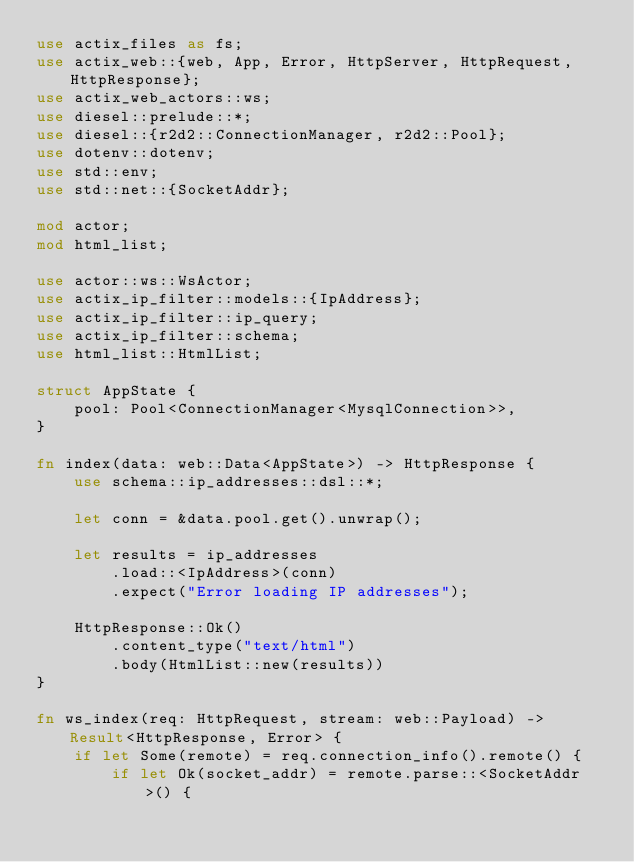<code> <loc_0><loc_0><loc_500><loc_500><_Rust_>use actix_files as fs;
use actix_web::{web, App, Error, HttpServer, HttpRequest, HttpResponse};
use actix_web_actors::ws;
use diesel::prelude::*;
use diesel::{r2d2::ConnectionManager, r2d2::Pool};
use dotenv::dotenv;
use std::env;
use std::net::{SocketAddr};

mod actor;
mod html_list;

use actor::ws::WsActor;
use actix_ip_filter::models::{IpAddress};
use actix_ip_filter::ip_query;
use actix_ip_filter::schema;
use html_list::HtmlList;

struct AppState {
    pool: Pool<ConnectionManager<MysqlConnection>>,
}

fn index(data: web::Data<AppState>) -> HttpResponse {
    use schema::ip_addresses::dsl::*;

    let conn = &data.pool.get().unwrap();

    let results = ip_addresses
        .load::<IpAddress>(conn)
        .expect("Error loading IP addresses");

    HttpResponse::Ok()
        .content_type("text/html")
        .body(HtmlList::new(results))
}

fn ws_index(req: HttpRequest, stream: web::Payload) -> Result<HttpResponse, Error> {
    if let Some(remote) = req.connection_info().remote() {
        if let Ok(socket_addr) = remote.parse::<SocketAddr>() {</code> 